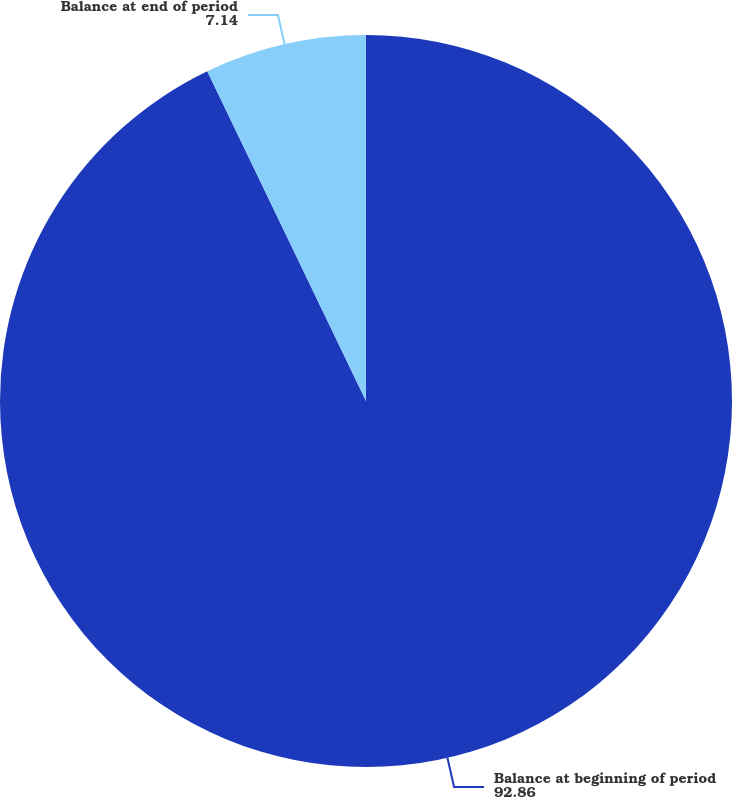Convert chart to OTSL. <chart><loc_0><loc_0><loc_500><loc_500><pie_chart><fcel>Balance at beginning of period<fcel>Balance at end of period<nl><fcel>92.86%<fcel>7.14%<nl></chart> 